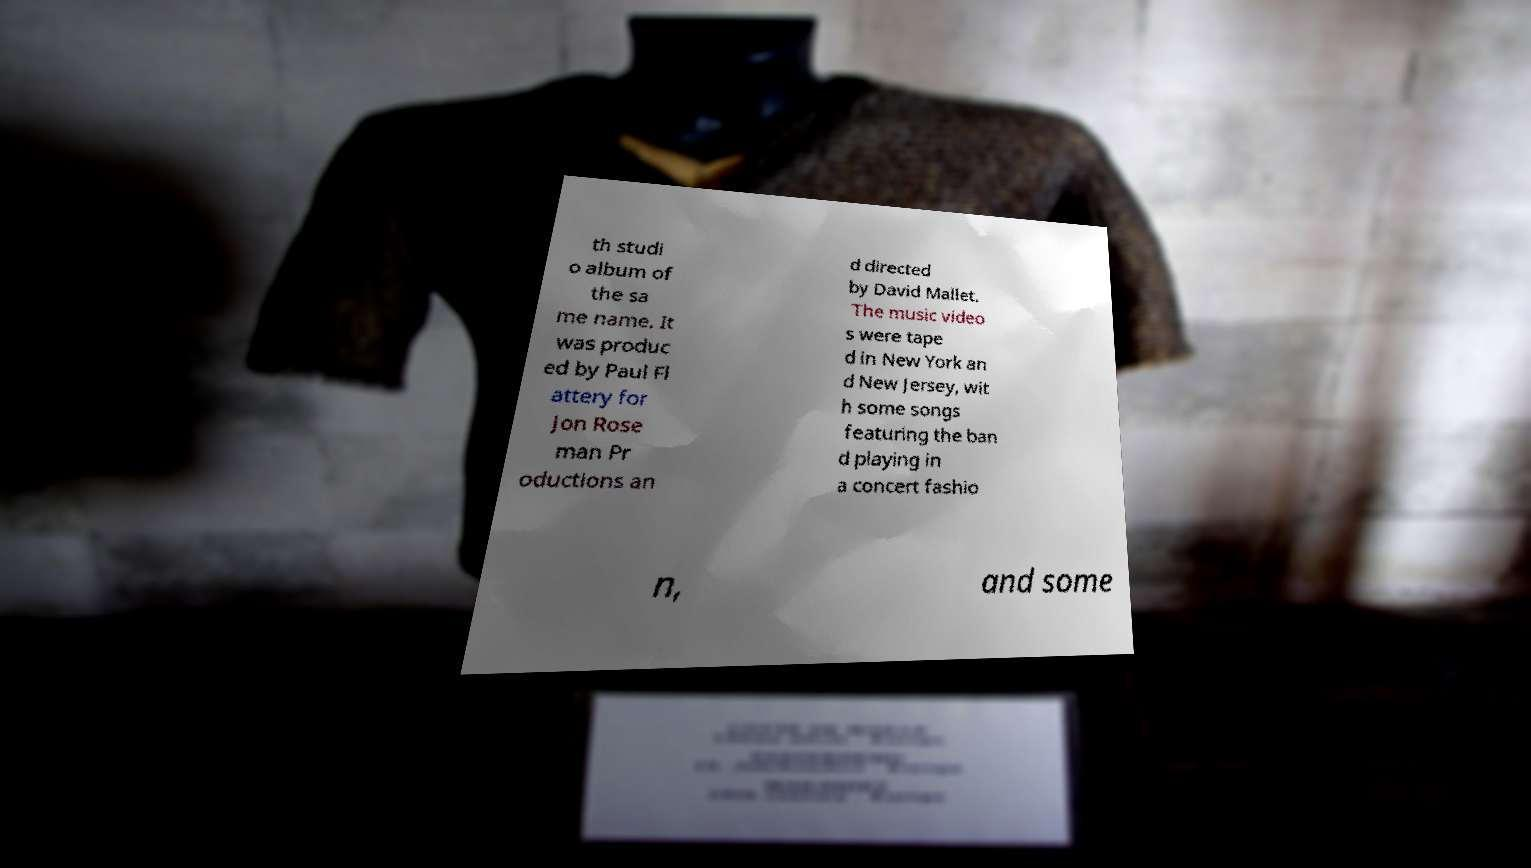Please identify and transcribe the text found in this image. th studi o album of the sa me name. It was produc ed by Paul Fl attery for Jon Rose man Pr oductions an d directed by David Mallet. The music video s were tape d in New York an d New Jersey, wit h some songs featuring the ban d playing in a concert fashio n, and some 